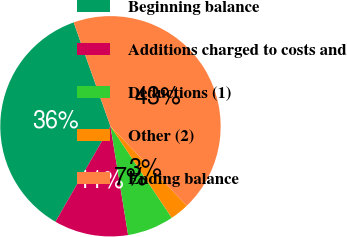<chart> <loc_0><loc_0><loc_500><loc_500><pie_chart><fcel>Beginning balance<fcel>Additions charged to costs and<fcel>Deductions (1)<fcel>Other (2)<fcel>Ending balance<nl><fcel>36.26%<fcel>10.88%<fcel>6.83%<fcel>2.79%<fcel>43.24%<nl></chart> 